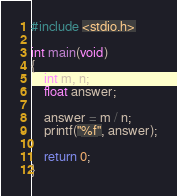<code> <loc_0><loc_0><loc_500><loc_500><_C_>#include <stdio.h>

int main(void)
{
    int m, n;
    float answer;

    answer = m / n;
    printf("%f", answer);

    return 0;
}</code> 